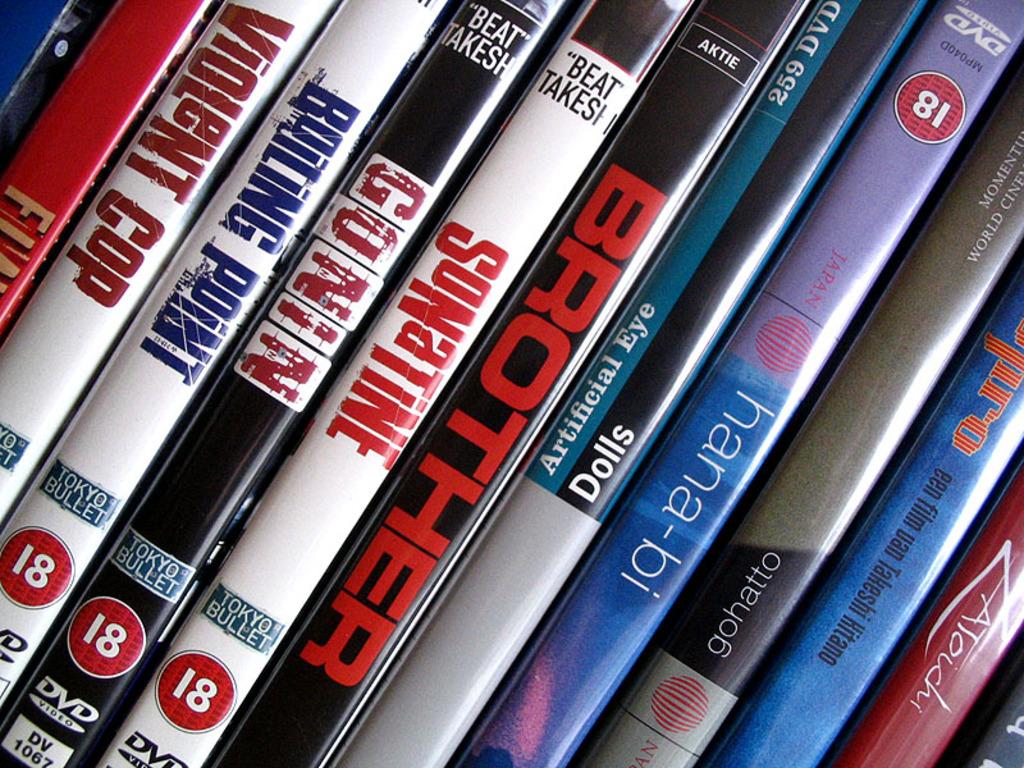What company published the sonatine dvd?
Your answer should be compact. Tokyo bullet. 